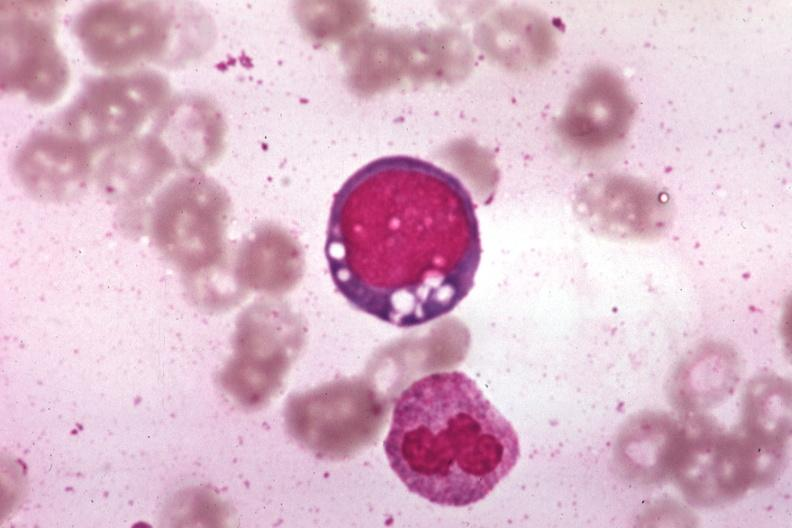what is present?
Answer the question using a single word or phrase. Bone marrow 